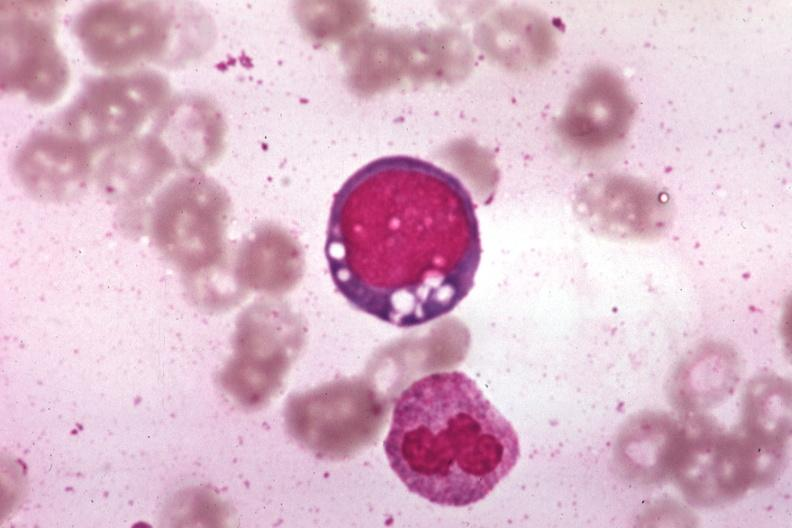what is present?
Answer the question using a single word or phrase. Bone marrow 